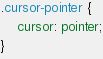Convert code to text. <code><loc_0><loc_0><loc_500><loc_500><_CSS_>

.cursor-pointer {
    cursor: pointer;
}</code> 